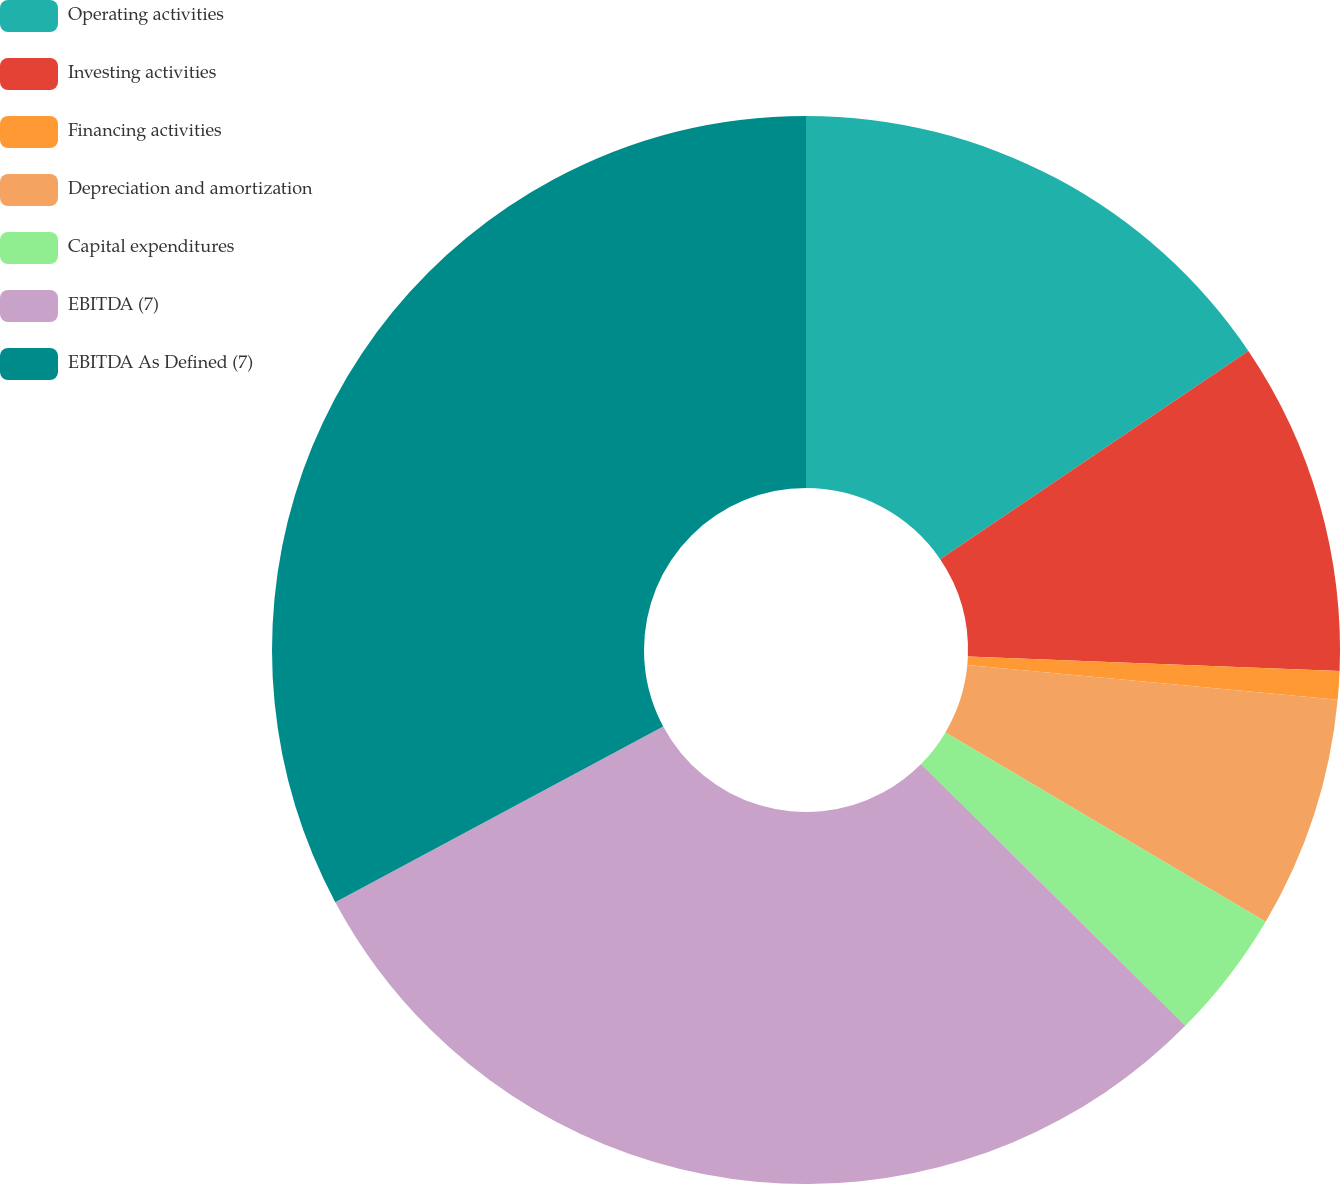Convert chart. <chart><loc_0><loc_0><loc_500><loc_500><pie_chart><fcel>Operating activities<fcel>Investing activities<fcel>Financing activities<fcel>Depreciation and amortization<fcel>Capital expenditures<fcel>EBITDA (7)<fcel>EBITDA As Defined (7)<nl><fcel>15.54%<fcel>10.09%<fcel>0.86%<fcel>7.01%<fcel>3.93%<fcel>29.75%<fcel>32.83%<nl></chart> 